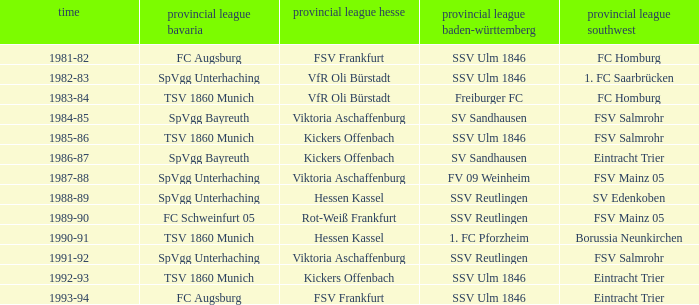Which Season ha spvgg bayreuth and eintracht trier? 1986-87. 